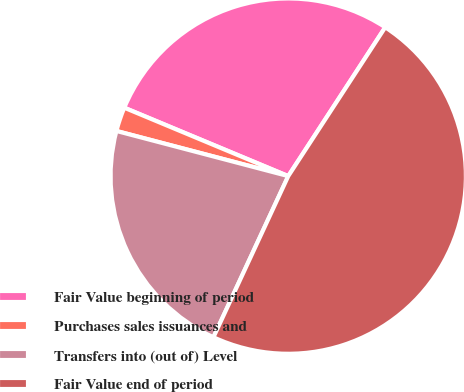Convert chart to OTSL. <chart><loc_0><loc_0><loc_500><loc_500><pie_chart><fcel>Fair Value beginning of period<fcel>Purchases sales issuances and<fcel>Transfers into (out of) Level<fcel>Fair Value end of period<nl><fcel>27.9%<fcel>2.2%<fcel>22.17%<fcel>47.72%<nl></chart> 